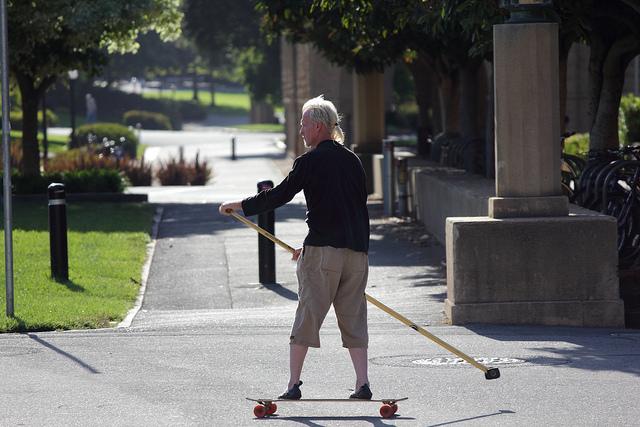What is the man riding?
Concise answer only. Skateboard. What type of foliage is in the background?
Concise answer only. Trees. What is the long stick for?
Quick response, please. Balance. 